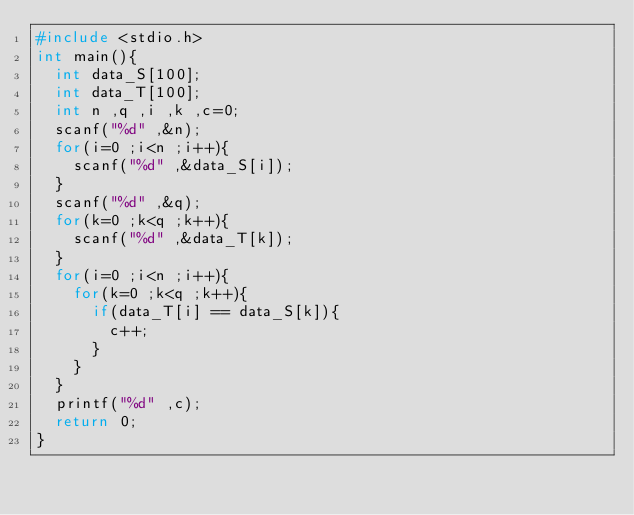<code> <loc_0><loc_0><loc_500><loc_500><_C_>#include <stdio.h>
int main(){
  int data_S[100];
  int data_T[100];
  int n ,q ,i ,k ,c=0;
  scanf("%d" ,&n);
  for(i=0 ;i<n ;i++){
    scanf("%d" ,&data_S[i]);
  }
  scanf("%d" ,&q);
  for(k=0 ;k<q ;k++){
    scanf("%d" ,&data_T[k]);
  }
  for(i=0 ;i<n ;i++){
    for(k=0 ;k<q ;k++){
      if(data_T[i] == data_S[k]){
        c++;
      }
    }
  }
  printf("%d" ,c);
  return 0;
}</code> 